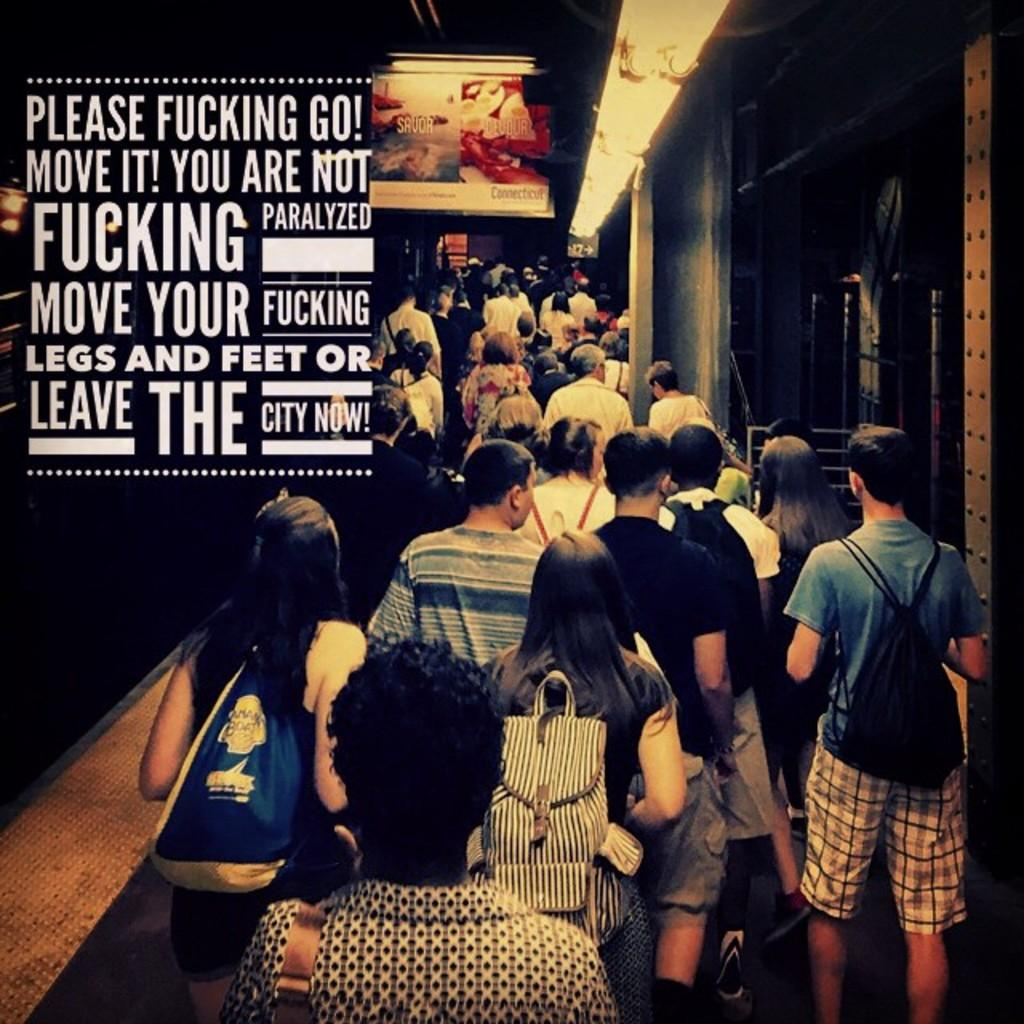What is the main subject of the image? The main subject of the image is people. Where are the people located in the image? The people are in the center of the image. What can be seen at the top side of the image? There is light at the top side of the image. What type of bushes can be seen growing in the image? There are no bushes present in the image. How much milk is being poured in the image? There is no milk present in the image. 